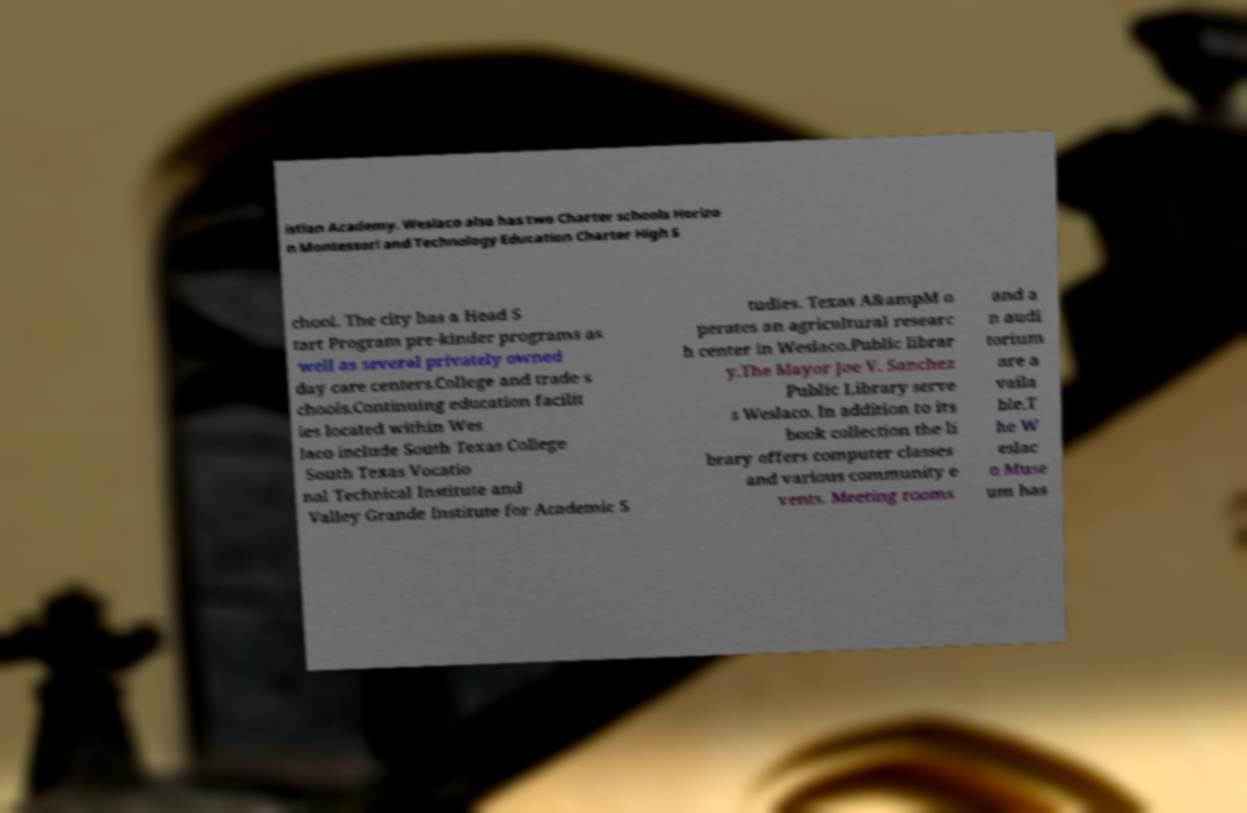For documentation purposes, I need the text within this image transcribed. Could you provide that? istian Academy. Weslaco also has two Charter schools Horizo n Montessori and Technology Education Charter High S chool. The city has a Head S tart Program pre-kinder programs as well as several privately owned day care centers.College and trade s chools.Continuing education facilit ies located within Wes laco include South Texas College South Texas Vocatio nal Technical Institute and Valley Grande Institute for Academic S tudies. Texas A&ampM o perates an agricultural researc h center in Weslaco.Public librar y.The Mayor Joe V. Sanchez Public Library serve s Weslaco. In addition to its book collection the li brary offers computer classes and various community e vents. Meeting rooms and a n audi torium are a vaila ble.T he W eslac o Muse um has 